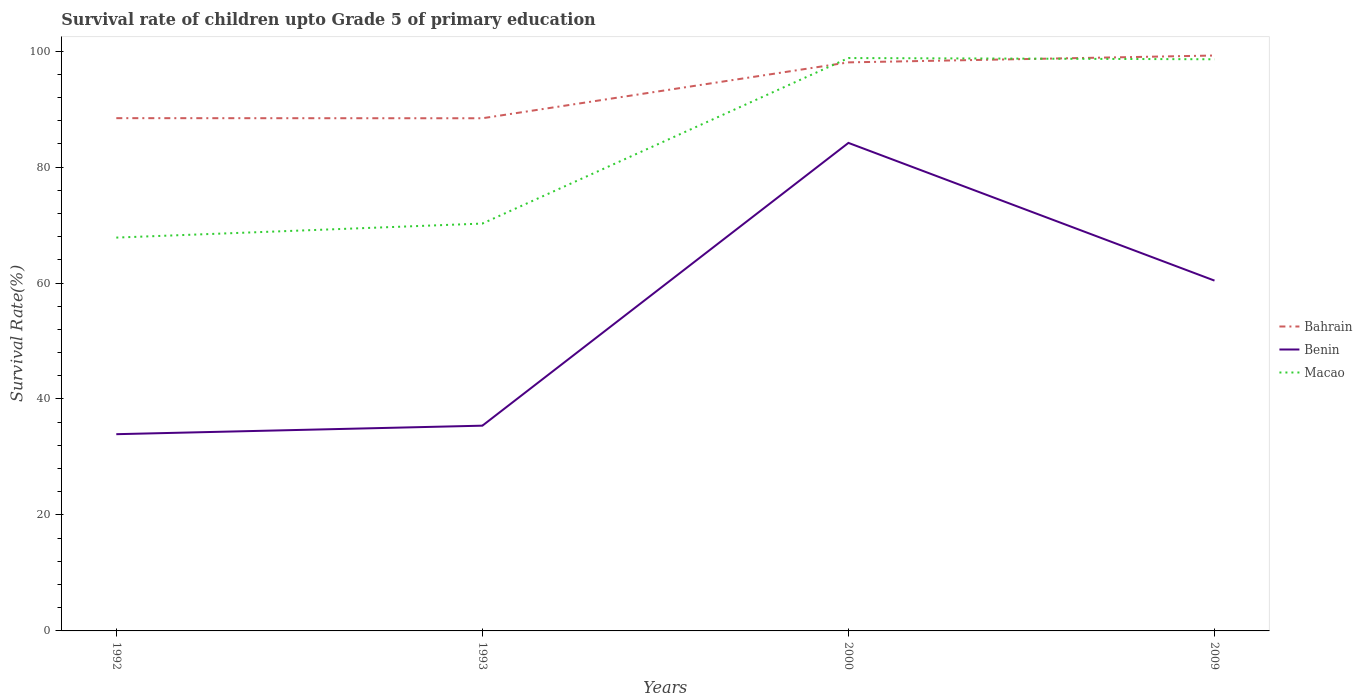How many different coloured lines are there?
Your answer should be compact. 3. Is the number of lines equal to the number of legend labels?
Offer a terse response. Yes. Across all years, what is the maximum survival rate of children in Macao?
Make the answer very short. 67.83. In which year was the survival rate of children in Benin maximum?
Your answer should be compact. 1992. What is the total survival rate of children in Benin in the graph?
Your answer should be compact. -25.02. What is the difference between the highest and the second highest survival rate of children in Bahrain?
Provide a succinct answer. 10.82. What is the difference between the highest and the lowest survival rate of children in Bahrain?
Ensure brevity in your answer.  2. Is the survival rate of children in Benin strictly greater than the survival rate of children in Bahrain over the years?
Offer a very short reply. Yes. What is the difference between two consecutive major ticks on the Y-axis?
Your answer should be compact. 20. Are the values on the major ticks of Y-axis written in scientific E-notation?
Your answer should be very brief. No. Where does the legend appear in the graph?
Your answer should be compact. Center right. How many legend labels are there?
Your answer should be very brief. 3. How are the legend labels stacked?
Provide a short and direct response. Vertical. What is the title of the graph?
Make the answer very short. Survival rate of children upto Grade 5 of primary education. What is the label or title of the Y-axis?
Offer a very short reply. Survival Rate(%). What is the Survival Rate(%) in Bahrain in 1992?
Ensure brevity in your answer.  88.43. What is the Survival Rate(%) in Benin in 1992?
Your answer should be compact. 33.93. What is the Survival Rate(%) in Macao in 1992?
Make the answer very short. 67.83. What is the Survival Rate(%) of Bahrain in 1993?
Give a very brief answer. 88.41. What is the Survival Rate(%) of Benin in 1993?
Ensure brevity in your answer.  35.4. What is the Survival Rate(%) in Macao in 1993?
Give a very brief answer. 70.25. What is the Survival Rate(%) in Bahrain in 2000?
Your answer should be very brief. 98.05. What is the Survival Rate(%) in Benin in 2000?
Give a very brief answer. 84.16. What is the Survival Rate(%) in Macao in 2000?
Offer a very short reply. 98.8. What is the Survival Rate(%) in Bahrain in 2009?
Your answer should be very brief. 99.24. What is the Survival Rate(%) of Benin in 2009?
Provide a short and direct response. 60.42. What is the Survival Rate(%) of Macao in 2009?
Offer a very short reply. 98.59. Across all years, what is the maximum Survival Rate(%) in Bahrain?
Provide a short and direct response. 99.24. Across all years, what is the maximum Survival Rate(%) of Benin?
Your response must be concise. 84.16. Across all years, what is the maximum Survival Rate(%) of Macao?
Offer a very short reply. 98.8. Across all years, what is the minimum Survival Rate(%) in Bahrain?
Offer a very short reply. 88.41. Across all years, what is the minimum Survival Rate(%) in Benin?
Make the answer very short. 33.93. Across all years, what is the minimum Survival Rate(%) in Macao?
Your response must be concise. 67.83. What is the total Survival Rate(%) of Bahrain in the graph?
Make the answer very short. 374.13. What is the total Survival Rate(%) of Benin in the graph?
Your answer should be compact. 213.91. What is the total Survival Rate(%) in Macao in the graph?
Ensure brevity in your answer.  335.47. What is the difference between the Survival Rate(%) of Bahrain in 1992 and that in 1993?
Your response must be concise. 0.02. What is the difference between the Survival Rate(%) of Benin in 1992 and that in 1993?
Keep it short and to the point. -1.47. What is the difference between the Survival Rate(%) in Macao in 1992 and that in 1993?
Provide a short and direct response. -2.42. What is the difference between the Survival Rate(%) of Bahrain in 1992 and that in 2000?
Provide a succinct answer. -9.62. What is the difference between the Survival Rate(%) of Benin in 1992 and that in 2000?
Make the answer very short. -50.23. What is the difference between the Survival Rate(%) of Macao in 1992 and that in 2000?
Keep it short and to the point. -30.96. What is the difference between the Survival Rate(%) in Bahrain in 1992 and that in 2009?
Your answer should be very brief. -10.8. What is the difference between the Survival Rate(%) of Benin in 1992 and that in 2009?
Ensure brevity in your answer.  -26.49. What is the difference between the Survival Rate(%) in Macao in 1992 and that in 2009?
Offer a terse response. -30.75. What is the difference between the Survival Rate(%) in Bahrain in 1993 and that in 2000?
Give a very brief answer. -9.64. What is the difference between the Survival Rate(%) of Benin in 1993 and that in 2000?
Your answer should be compact. -48.77. What is the difference between the Survival Rate(%) in Macao in 1993 and that in 2000?
Offer a terse response. -28.54. What is the difference between the Survival Rate(%) in Bahrain in 1993 and that in 2009?
Give a very brief answer. -10.82. What is the difference between the Survival Rate(%) in Benin in 1993 and that in 2009?
Make the answer very short. -25.02. What is the difference between the Survival Rate(%) in Macao in 1993 and that in 2009?
Offer a terse response. -28.33. What is the difference between the Survival Rate(%) of Bahrain in 2000 and that in 2009?
Offer a terse response. -1.18. What is the difference between the Survival Rate(%) of Benin in 2000 and that in 2009?
Give a very brief answer. 23.75. What is the difference between the Survival Rate(%) in Macao in 2000 and that in 2009?
Provide a succinct answer. 0.21. What is the difference between the Survival Rate(%) in Bahrain in 1992 and the Survival Rate(%) in Benin in 1993?
Offer a terse response. 53.04. What is the difference between the Survival Rate(%) of Bahrain in 1992 and the Survival Rate(%) of Macao in 1993?
Your response must be concise. 18.18. What is the difference between the Survival Rate(%) of Benin in 1992 and the Survival Rate(%) of Macao in 1993?
Ensure brevity in your answer.  -36.32. What is the difference between the Survival Rate(%) of Bahrain in 1992 and the Survival Rate(%) of Benin in 2000?
Keep it short and to the point. 4.27. What is the difference between the Survival Rate(%) in Bahrain in 1992 and the Survival Rate(%) in Macao in 2000?
Provide a succinct answer. -10.37. What is the difference between the Survival Rate(%) in Benin in 1992 and the Survival Rate(%) in Macao in 2000?
Your response must be concise. -64.87. What is the difference between the Survival Rate(%) in Bahrain in 1992 and the Survival Rate(%) in Benin in 2009?
Keep it short and to the point. 28.02. What is the difference between the Survival Rate(%) of Bahrain in 1992 and the Survival Rate(%) of Macao in 2009?
Your answer should be compact. -10.15. What is the difference between the Survival Rate(%) of Benin in 1992 and the Survival Rate(%) of Macao in 2009?
Offer a terse response. -64.66. What is the difference between the Survival Rate(%) in Bahrain in 1993 and the Survival Rate(%) in Benin in 2000?
Ensure brevity in your answer.  4.25. What is the difference between the Survival Rate(%) in Bahrain in 1993 and the Survival Rate(%) in Macao in 2000?
Provide a succinct answer. -10.38. What is the difference between the Survival Rate(%) of Benin in 1993 and the Survival Rate(%) of Macao in 2000?
Offer a terse response. -63.4. What is the difference between the Survival Rate(%) in Bahrain in 1993 and the Survival Rate(%) in Benin in 2009?
Offer a very short reply. 28. What is the difference between the Survival Rate(%) in Bahrain in 1993 and the Survival Rate(%) in Macao in 2009?
Keep it short and to the point. -10.17. What is the difference between the Survival Rate(%) of Benin in 1993 and the Survival Rate(%) of Macao in 2009?
Your answer should be compact. -63.19. What is the difference between the Survival Rate(%) in Bahrain in 2000 and the Survival Rate(%) in Benin in 2009?
Your response must be concise. 37.64. What is the difference between the Survival Rate(%) of Bahrain in 2000 and the Survival Rate(%) of Macao in 2009?
Your answer should be compact. -0.53. What is the difference between the Survival Rate(%) of Benin in 2000 and the Survival Rate(%) of Macao in 2009?
Make the answer very short. -14.42. What is the average Survival Rate(%) of Bahrain per year?
Your answer should be compact. 93.53. What is the average Survival Rate(%) of Benin per year?
Your response must be concise. 53.48. What is the average Survival Rate(%) in Macao per year?
Provide a succinct answer. 83.87. In the year 1992, what is the difference between the Survival Rate(%) in Bahrain and Survival Rate(%) in Benin?
Offer a very short reply. 54.5. In the year 1992, what is the difference between the Survival Rate(%) of Bahrain and Survival Rate(%) of Macao?
Give a very brief answer. 20.6. In the year 1992, what is the difference between the Survival Rate(%) in Benin and Survival Rate(%) in Macao?
Your response must be concise. -33.9. In the year 1993, what is the difference between the Survival Rate(%) of Bahrain and Survival Rate(%) of Benin?
Give a very brief answer. 53.02. In the year 1993, what is the difference between the Survival Rate(%) in Bahrain and Survival Rate(%) in Macao?
Your answer should be compact. 18.16. In the year 1993, what is the difference between the Survival Rate(%) of Benin and Survival Rate(%) of Macao?
Give a very brief answer. -34.86. In the year 2000, what is the difference between the Survival Rate(%) in Bahrain and Survival Rate(%) in Benin?
Provide a succinct answer. 13.89. In the year 2000, what is the difference between the Survival Rate(%) of Bahrain and Survival Rate(%) of Macao?
Your response must be concise. -0.75. In the year 2000, what is the difference between the Survival Rate(%) in Benin and Survival Rate(%) in Macao?
Make the answer very short. -14.63. In the year 2009, what is the difference between the Survival Rate(%) in Bahrain and Survival Rate(%) in Benin?
Your answer should be compact. 38.82. In the year 2009, what is the difference between the Survival Rate(%) in Bahrain and Survival Rate(%) in Macao?
Give a very brief answer. 0.65. In the year 2009, what is the difference between the Survival Rate(%) in Benin and Survival Rate(%) in Macao?
Your response must be concise. -38.17. What is the ratio of the Survival Rate(%) in Bahrain in 1992 to that in 1993?
Make the answer very short. 1. What is the ratio of the Survival Rate(%) of Benin in 1992 to that in 1993?
Your response must be concise. 0.96. What is the ratio of the Survival Rate(%) in Macao in 1992 to that in 1993?
Provide a succinct answer. 0.97. What is the ratio of the Survival Rate(%) in Bahrain in 1992 to that in 2000?
Ensure brevity in your answer.  0.9. What is the ratio of the Survival Rate(%) of Benin in 1992 to that in 2000?
Your answer should be compact. 0.4. What is the ratio of the Survival Rate(%) of Macao in 1992 to that in 2000?
Keep it short and to the point. 0.69. What is the ratio of the Survival Rate(%) of Bahrain in 1992 to that in 2009?
Provide a short and direct response. 0.89. What is the ratio of the Survival Rate(%) of Benin in 1992 to that in 2009?
Provide a short and direct response. 0.56. What is the ratio of the Survival Rate(%) of Macao in 1992 to that in 2009?
Your answer should be compact. 0.69. What is the ratio of the Survival Rate(%) of Bahrain in 1993 to that in 2000?
Provide a short and direct response. 0.9. What is the ratio of the Survival Rate(%) of Benin in 1993 to that in 2000?
Give a very brief answer. 0.42. What is the ratio of the Survival Rate(%) of Macao in 1993 to that in 2000?
Keep it short and to the point. 0.71. What is the ratio of the Survival Rate(%) of Bahrain in 1993 to that in 2009?
Ensure brevity in your answer.  0.89. What is the ratio of the Survival Rate(%) of Benin in 1993 to that in 2009?
Your answer should be very brief. 0.59. What is the ratio of the Survival Rate(%) of Macao in 1993 to that in 2009?
Give a very brief answer. 0.71. What is the ratio of the Survival Rate(%) of Benin in 2000 to that in 2009?
Your response must be concise. 1.39. What is the ratio of the Survival Rate(%) in Macao in 2000 to that in 2009?
Give a very brief answer. 1. What is the difference between the highest and the second highest Survival Rate(%) of Bahrain?
Provide a succinct answer. 1.18. What is the difference between the highest and the second highest Survival Rate(%) of Benin?
Provide a succinct answer. 23.75. What is the difference between the highest and the second highest Survival Rate(%) in Macao?
Offer a very short reply. 0.21. What is the difference between the highest and the lowest Survival Rate(%) of Bahrain?
Give a very brief answer. 10.82. What is the difference between the highest and the lowest Survival Rate(%) in Benin?
Your answer should be compact. 50.23. What is the difference between the highest and the lowest Survival Rate(%) of Macao?
Your answer should be compact. 30.96. 